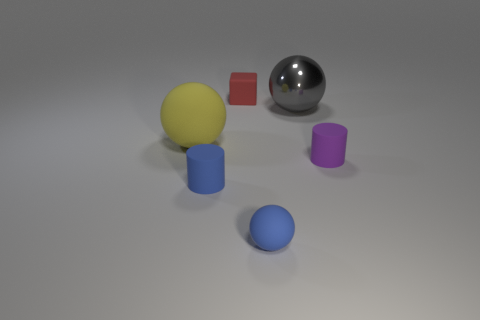Add 4 large gray metallic spheres. How many objects exist? 10 Subtract all cylinders. How many objects are left? 4 Add 1 small red rubber things. How many small red rubber things are left? 2 Add 2 red things. How many red things exist? 3 Subtract 1 red blocks. How many objects are left? 5 Subtract all blue blocks. Subtract all shiny spheres. How many objects are left? 5 